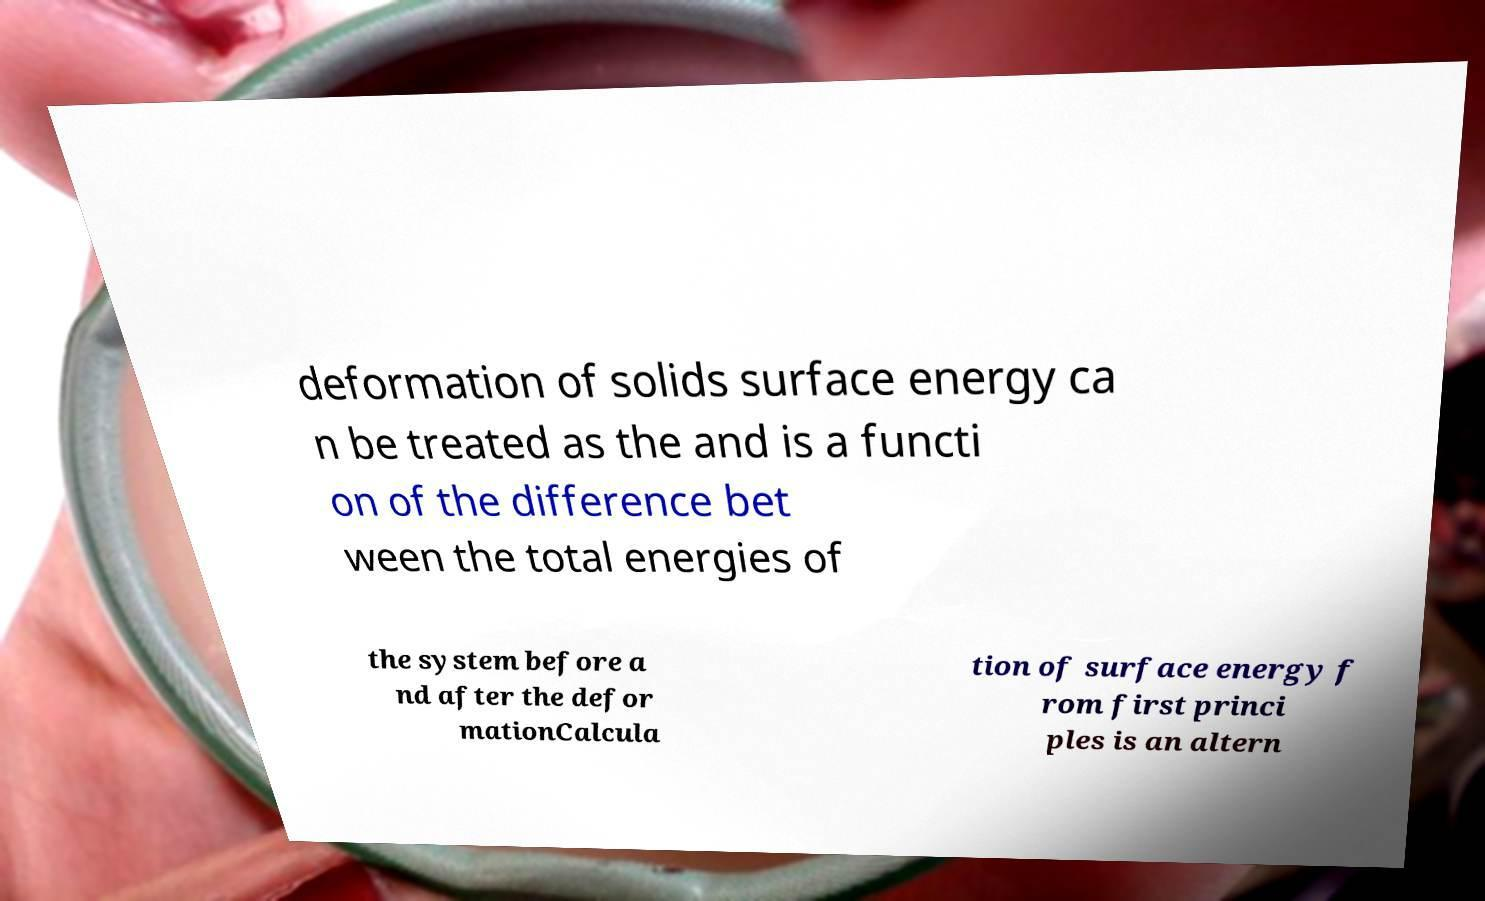Can you read and provide the text displayed in the image?This photo seems to have some interesting text. Can you extract and type it out for me? deformation of solids surface energy ca n be treated as the and is a functi on of the difference bet ween the total energies of the system before a nd after the defor mationCalcula tion of surface energy f rom first princi ples is an altern 